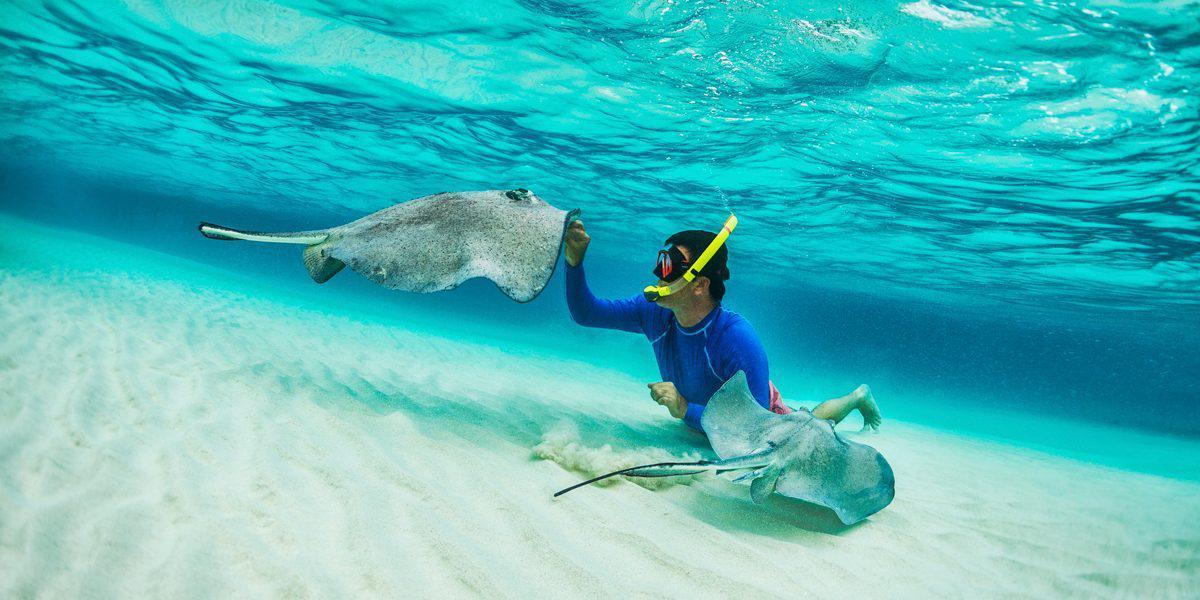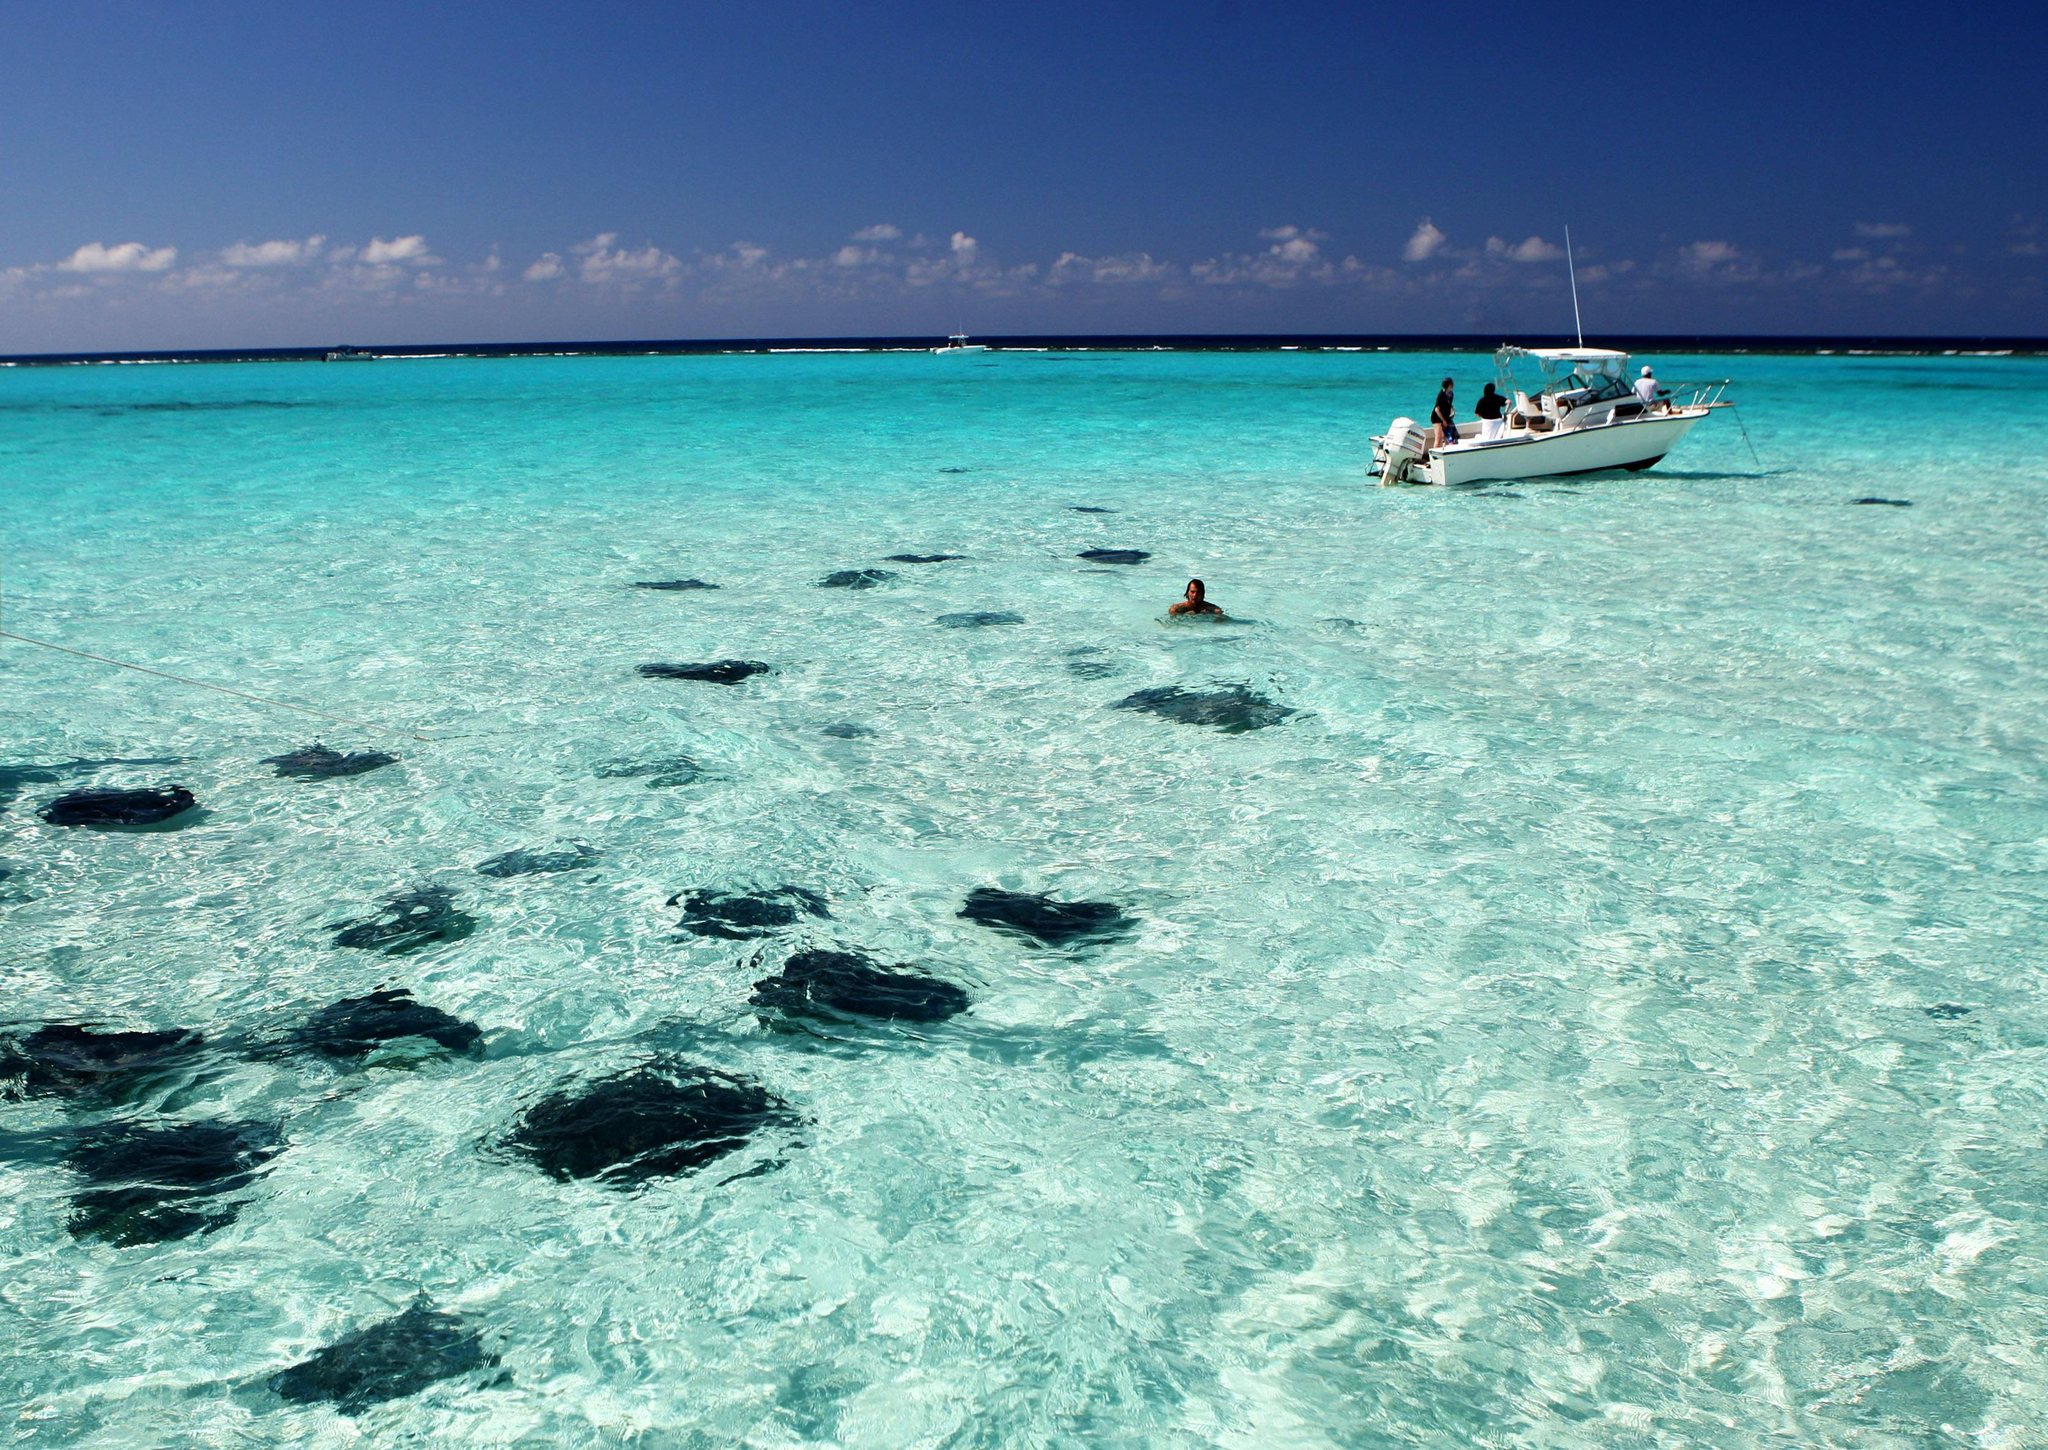The first image is the image on the left, the second image is the image on the right. For the images shown, is this caption "There is at least one human in the ocean in the left image." true? Answer yes or no. Yes. The first image is the image on the left, the second image is the image on the right. Assess this claim about the two images: "Each image contains people in a body of water with rays in it.". Correct or not? Answer yes or no. Yes. 